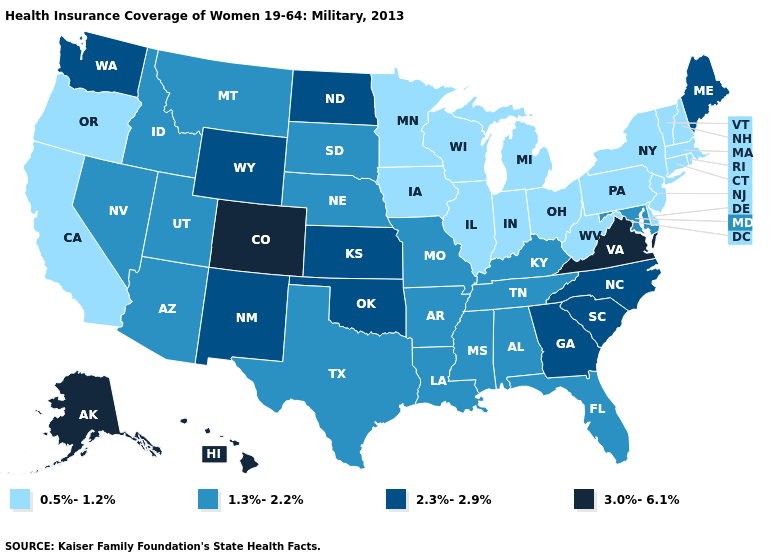Name the states that have a value in the range 0.5%-1.2%?
Keep it brief. California, Connecticut, Delaware, Illinois, Indiana, Iowa, Massachusetts, Michigan, Minnesota, New Hampshire, New Jersey, New York, Ohio, Oregon, Pennsylvania, Rhode Island, Vermont, West Virginia, Wisconsin. Is the legend a continuous bar?
Short answer required. No. What is the value of North Carolina?
Be succinct. 2.3%-2.9%. Name the states that have a value in the range 3.0%-6.1%?
Keep it brief. Alaska, Colorado, Hawaii, Virginia. Does Wyoming have the lowest value in the USA?
Answer briefly. No. What is the value of Wisconsin?
Write a very short answer. 0.5%-1.2%. Does New York have the lowest value in the USA?
Give a very brief answer. Yes. Does the first symbol in the legend represent the smallest category?
Write a very short answer. Yes. What is the value of Kansas?
Keep it brief. 2.3%-2.9%. What is the highest value in the USA?
Write a very short answer. 3.0%-6.1%. Does the first symbol in the legend represent the smallest category?
Be succinct. Yes. Which states have the lowest value in the USA?
Give a very brief answer. California, Connecticut, Delaware, Illinois, Indiana, Iowa, Massachusetts, Michigan, Minnesota, New Hampshire, New Jersey, New York, Ohio, Oregon, Pennsylvania, Rhode Island, Vermont, West Virginia, Wisconsin. What is the lowest value in the South?
Give a very brief answer. 0.5%-1.2%. Which states hav the highest value in the MidWest?
Be succinct. Kansas, North Dakota. What is the value of Oregon?
Be succinct. 0.5%-1.2%. 